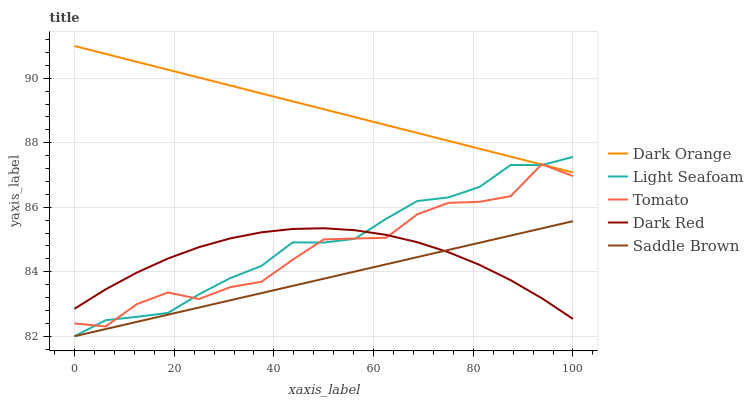Does Saddle Brown have the minimum area under the curve?
Answer yes or no. Yes. Does Dark Orange have the maximum area under the curve?
Answer yes or no. Yes. Does Light Seafoam have the minimum area under the curve?
Answer yes or no. No. Does Light Seafoam have the maximum area under the curve?
Answer yes or no. No. Is Dark Orange the smoothest?
Answer yes or no. Yes. Is Tomato the roughest?
Answer yes or no. Yes. Is Light Seafoam the smoothest?
Answer yes or no. No. Is Light Seafoam the roughest?
Answer yes or no. No. Does Light Seafoam have the lowest value?
Answer yes or no. Yes. Does Dark Orange have the lowest value?
Answer yes or no. No. Does Dark Orange have the highest value?
Answer yes or no. Yes. Does Light Seafoam have the highest value?
Answer yes or no. No. Is Dark Red less than Dark Orange?
Answer yes or no. Yes. Is Tomato greater than Saddle Brown?
Answer yes or no. Yes. Does Light Seafoam intersect Saddle Brown?
Answer yes or no. Yes. Is Light Seafoam less than Saddle Brown?
Answer yes or no. No. Is Light Seafoam greater than Saddle Brown?
Answer yes or no. No. Does Dark Red intersect Dark Orange?
Answer yes or no. No. 